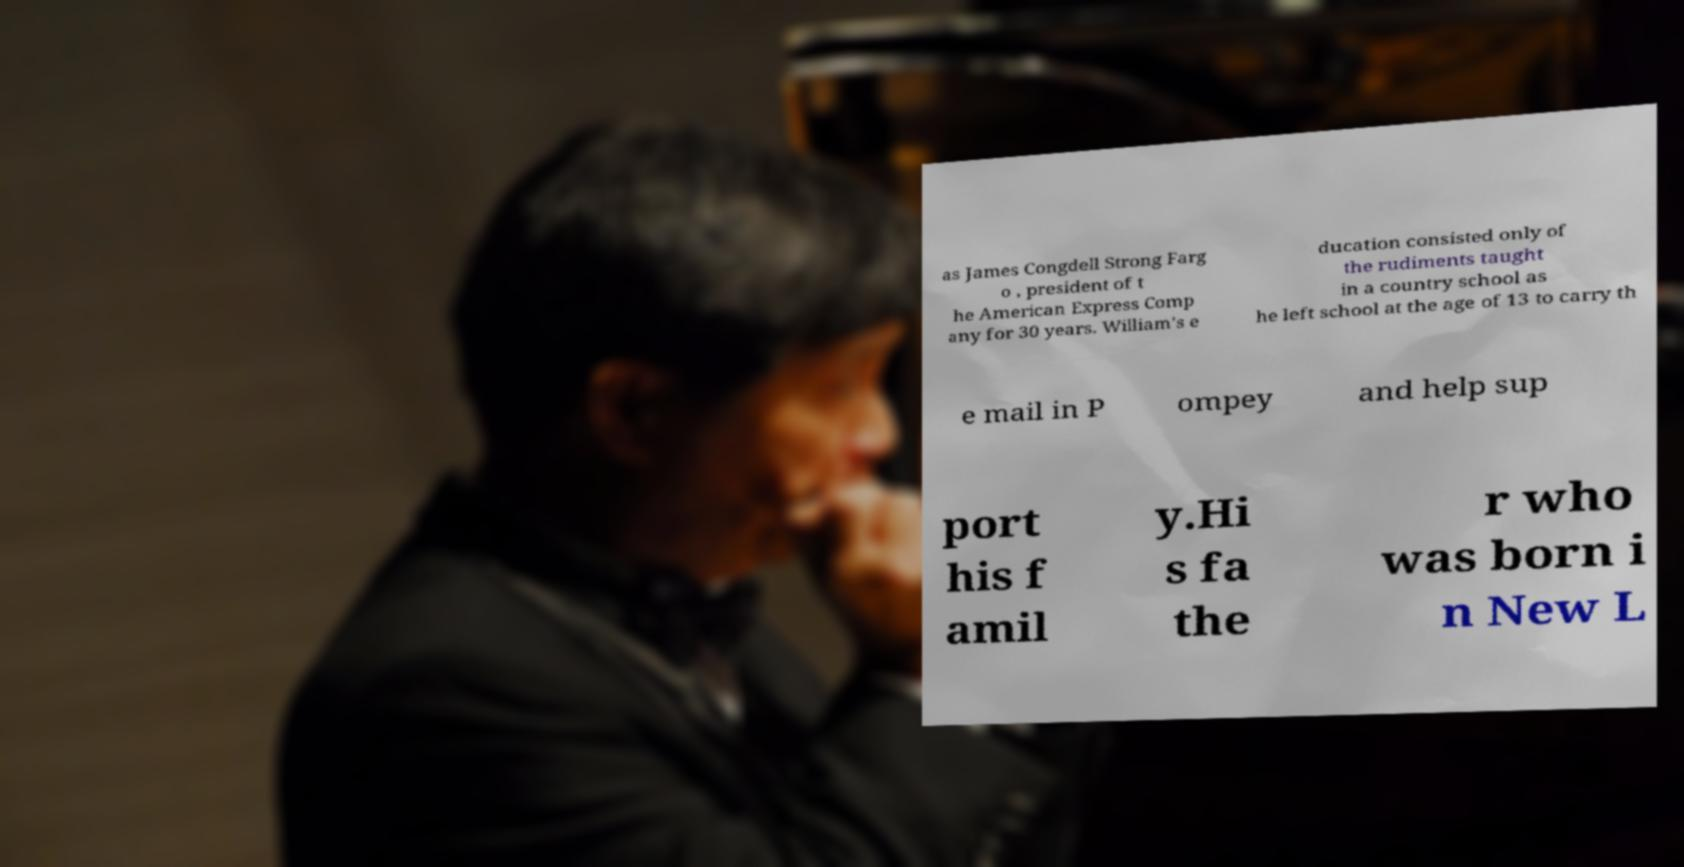There's text embedded in this image that I need extracted. Can you transcribe it verbatim? as James Congdell Strong Farg o , president of t he American Express Comp any for 30 years. William's e ducation consisted only of the rudiments taught in a country school as he left school at the age of 13 to carry th e mail in P ompey and help sup port his f amil y.Hi s fa the r who was born i n New L 